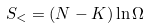<formula> <loc_0><loc_0><loc_500><loc_500>S _ { < } = ( N - K ) \ln \Omega</formula> 